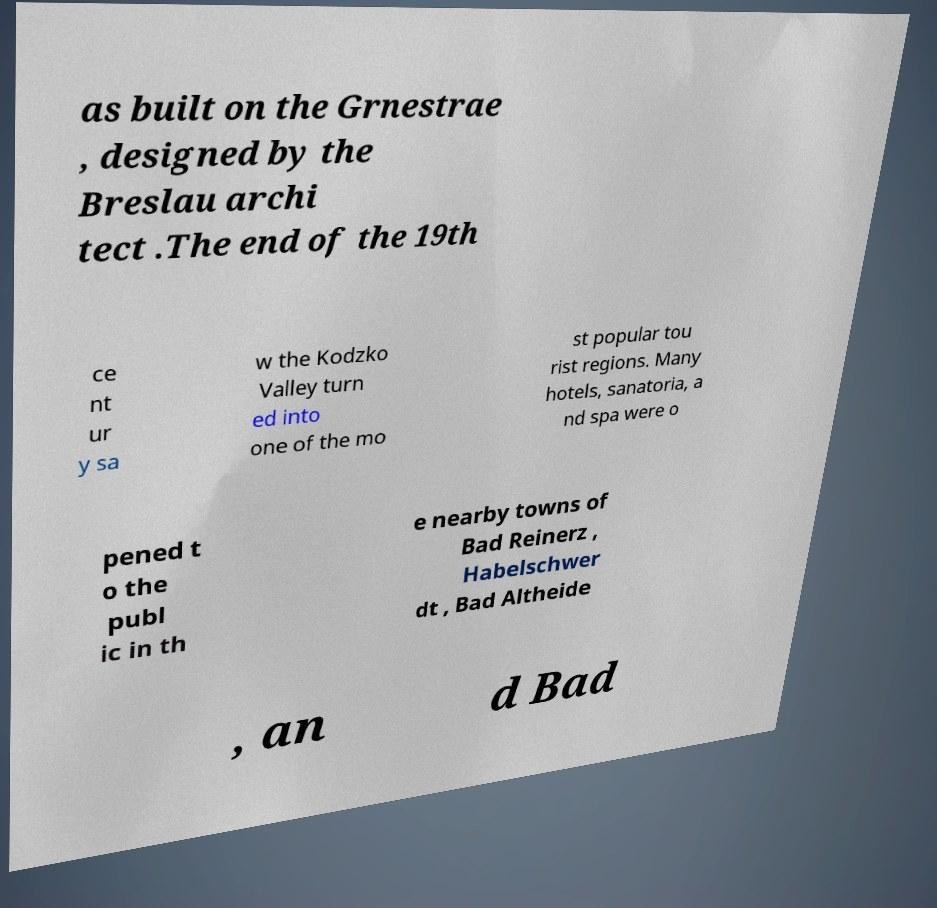Can you read and provide the text displayed in the image?This photo seems to have some interesting text. Can you extract and type it out for me? as built on the Grnestrae , designed by the Breslau archi tect .The end of the 19th ce nt ur y sa w the Kodzko Valley turn ed into one of the mo st popular tou rist regions. Many hotels, sanatoria, a nd spa were o pened t o the publ ic in th e nearby towns of Bad Reinerz , Habelschwer dt , Bad Altheide , an d Bad 